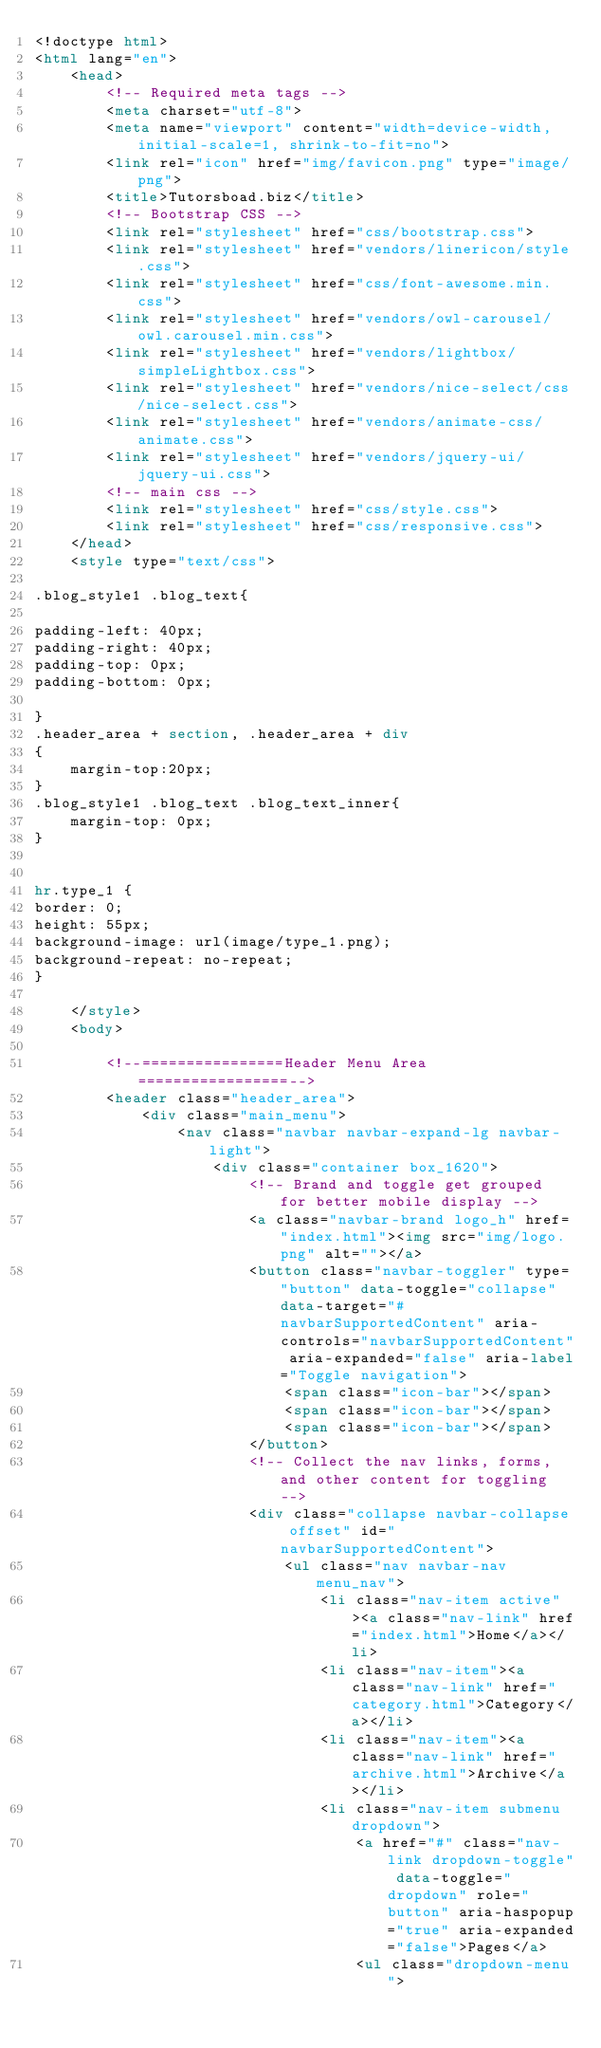Convert code to text. <code><loc_0><loc_0><loc_500><loc_500><_HTML_><!doctype html>
<html lang="en">
    <head>
        <!-- Required meta tags -->
        <meta charset="utf-8">
        <meta name="viewport" content="width=device-width, initial-scale=1, shrink-to-fit=no">
        <link rel="icon" href="img/favicon.png" type="image/png">
        <title>Tutorsboad.biz</title>
        <!-- Bootstrap CSS -->
        <link rel="stylesheet" href="css/bootstrap.css">
        <link rel="stylesheet" href="vendors/linericon/style.css">
        <link rel="stylesheet" href="css/font-awesome.min.css">
        <link rel="stylesheet" href="vendors/owl-carousel/owl.carousel.min.css">
        <link rel="stylesheet" href="vendors/lightbox/simpleLightbox.css">
        <link rel="stylesheet" href="vendors/nice-select/css/nice-select.css">
        <link rel="stylesheet" href="vendors/animate-css/animate.css">
        <link rel="stylesheet" href="vendors/jquery-ui/jquery-ui.css">
        <!-- main css -->
        <link rel="stylesheet" href="css/style.css">
        <link rel="stylesheet" href="css/responsive.css">
    </head>
    <style type="text/css">
    	
.blog_style1 .blog_text{
    
padding-left: 40px;
padding-right: 40px;
padding-top: 0px;
padding-bottom: 0px;

}
.header_area + section, .header_area + div
{
	margin-top:20px;
}
.blog_style1 .blog_text .blog_text_inner{
	margin-top: 0px;
}


hr.type_1 {
border: 0;
height: 55px;
background-image: url(image/type_1.png);
background-repeat: no-repeat;
}

    </style>
    <body>
        
        <!--================Header Menu Area =================-->
        <header class="header_area">
			<div class="main_menu">
				<nav class="navbar navbar-expand-lg navbar-light">
					<div class="container box_1620">
						<!-- Brand and toggle get grouped for better mobile display -->
						<a class="navbar-brand logo_h" href="index.html"><img src="img/logo.png" alt=""></a>
						<button class="navbar-toggler" type="button" data-toggle="collapse" data-target="#navbarSupportedContent" aria-controls="navbarSupportedContent" aria-expanded="false" aria-label="Toggle navigation">
							<span class="icon-bar"></span>
							<span class="icon-bar"></span>
							<span class="icon-bar"></span>
						</button>
						<!-- Collect the nav links, forms, and other content for toggling -->
						<div class="collapse navbar-collapse offset" id="navbarSupportedContent">
							<ul class="nav navbar-nav menu_nav">
								<li class="nav-item active"><a class="nav-link" href="index.html">Home</a></li> 
								<li class="nav-item"><a class="nav-link" href="category.html">Category</a></li>
								<li class="nav-item"><a class="nav-link" href="archive.html">Archive</a></li>
								<li class="nav-item submenu dropdown">
									<a href="#" class="nav-link dropdown-toggle" data-toggle="dropdown" role="button" aria-haspopup="true" aria-expanded="false">Pages</a>
									<ul class="dropdown-menu"></code> 